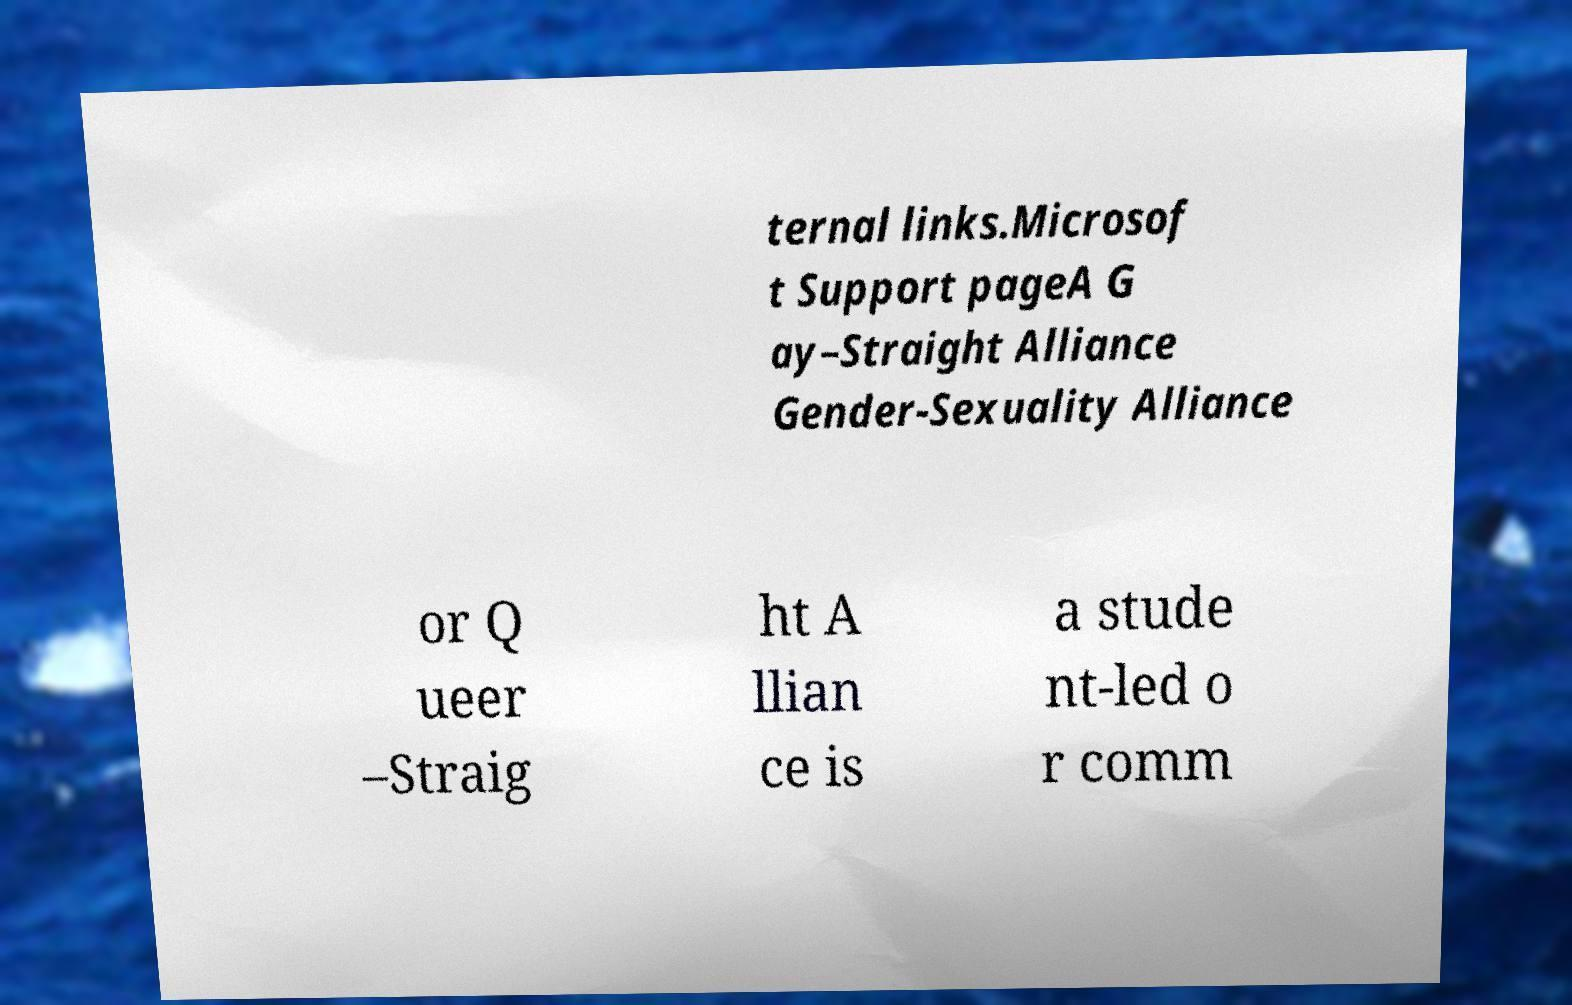Could you assist in decoding the text presented in this image and type it out clearly? ternal links.Microsof t Support pageA G ay–Straight Alliance Gender-Sexuality Alliance or Q ueer –Straig ht A llian ce is a stude nt-led o r comm 